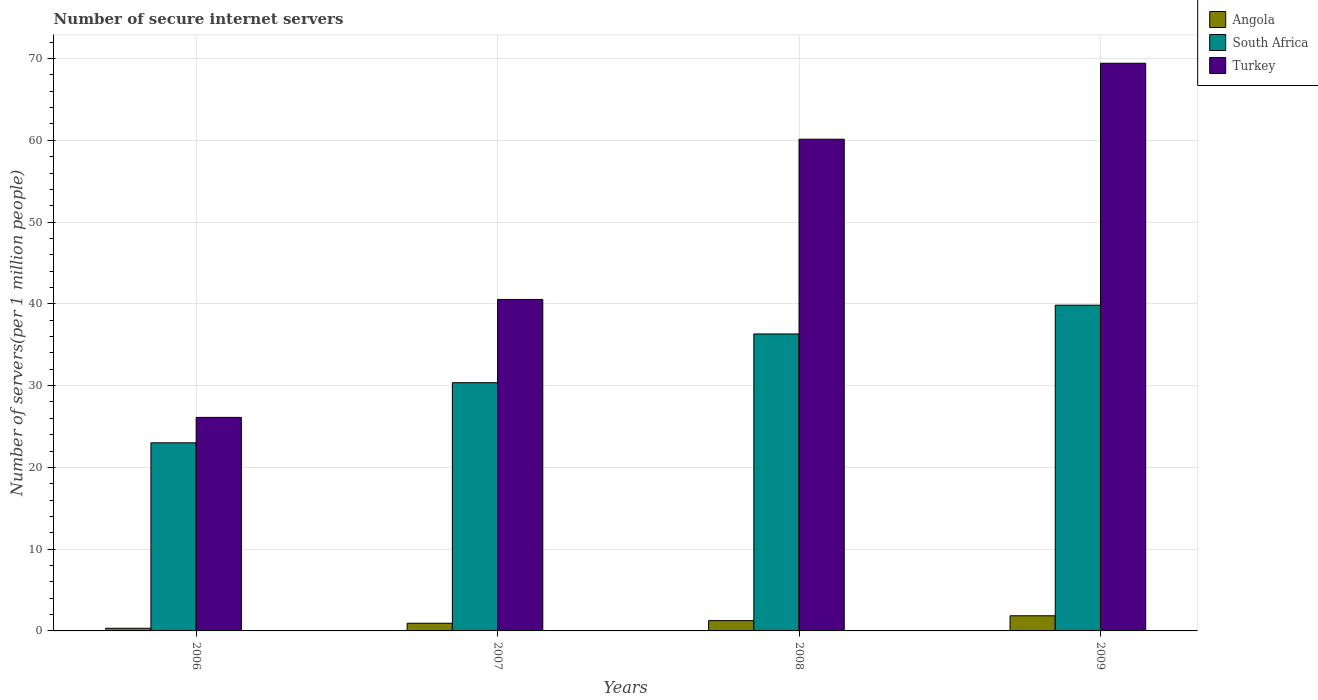Are the number of bars per tick equal to the number of legend labels?
Provide a short and direct response. Yes. Are the number of bars on each tick of the X-axis equal?
Your answer should be very brief. Yes. How many bars are there on the 3rd tick from the right?
Your response must be concise. 3. What is the number of secure internet servers in South Africa in 2009?
Your answer should be very brief. 39.84. Across all years, what is the maximum number of secure internet servers in Turkey?
Offer a very short reply. 69.42. Across all years, what is the minimum number of secure internet servers in Angola?
Your response must be concise. 0.32. In which year was the number of secure internet servers in Turkey minimum?
Give a very brief answer. 2006. What is the total number of secure internet servers in Turkey in the graph?
Your answer should be compact. 196.2. What is the difference between the number of secure internet servers in South Africa in 2007 and that in 2008?
Make the answer very short. -5.96. What is the difference between the number of secure internet servers in South Africa in 2008 and the number of secure internet servers in Angola in 2006?
Your answer should be compact. 35.99. What is the average number of secure internet servers in South Africa per year?
Your response must be concise. 32.38. In the year 2008, what is the difference between the number of secure internet servers in South Africa and number of secure internet servers in Turkey?
Provide a short and direct response. -23.82. In how many years, is the number of secure internet servers in South Africa greater than 2?
Provide a short and direct response. 4. What is the ratio of the number of secure internet servers in South Africa in 2006 to that in 2008?
Give a very brief answer. 0.63. Is the number of secure internet servers in Turkey in 2008 less than that in 2009?
Ensure brevity in your answer.  Yes. Is the difference between the number of secure internet servers in South Africa in 2006 and 2009 greater than the difference between the number of secure internet servers in Turkey in 2006 and 2009?
Keep it short and to the point. Yes. What is the difference between the highest and the second highest number of secure internet servers in Turkey?
Provide a short and direct response. 9.29. What is the difference between the highest and the lowest number of secure internet servers in South Africa?
Ensure brevity in your answer.  16.83. Is the sum of the number of secure internet servers in Angola in 2006 and 2007 greater than the maximum number of secure internet servers in Turkey across all years?
Your answer should be very brief. No. What does the 2nd bar from the left in 2006 represents?
Ensure brevity in your answer.  South Africa. What does the 2nd bar from the right in 2009 represents?
Make the answer very short. South Africa. How many bars are there?
Provide a succinct answer. 12. Are the values on the major ticks of Y-axis written in scientific E-notation?
Your answer should be compact. No. Does the graph contain any zero values?
Offer a very short reply. No. What is the title of the graph?
Provide a succinct answer. Number of secure internet servers. What is the label or title of the Y-axis?
Give a very brief answer. Number of servers(per 1 million people). What is the Number of servers(per 1 million people) of Angola in 2006?
Your answer should be compact. 0.32. What is the Number of servers(per 1 million people) in South Africa in 2006?
Your response must be concise. 23. What is the Number of servers(per 1 million people) of Turkey in 2006?
Provide a succinct answer. 26.11. What is the Number of servers(per 1 million people) of Angola in 2007?
Your response must be concise. 0.94. What is the Number of servers(per 1 million people) of South Africa in 2007?
Offer a terse response. 30.36. What is the Number of servers(per 1 million people) of Turkey in 2007?
Ensure brevity in your answer.  40.54. What is the Number of servers(per 1 million people) of Angola in 2008?
Your response must be concise. 1.26. What is the Number of servers(per 1 million people) of South Africa in 2008?
Give a very brief answer. 36.32. What is the Number of servers(per 1 million people) in Turkey in 2008?
Your answer should be compact. 60.13. What is the Number of servers(per 1 million people) of Angola in 2009?
Make the answer very short. 1.85. What is the Number of servers(per 1 million people) of South Africa in 2009?
Give a very brief answer. 39.84. What is the Number of servers(per 1 million people) of Turkey in 2009?
Keep it short and to the point. 69.42. Across all years, what is the maximum Number of servers(per 1 million people) of Angola?
Ensure brevity in your answer.  1.85. Across all years, what is the maximum Number of servers(per 1 million people) of South Africa?
Keep it short and to the point. 39.84. Across all years, what is the maximum Number of servers(per 1 million people) in Turkey?
Provide a succinct answer. 69.42. Across all years, what is the minimum Number of servers(per 1 million people) of Angola?
Provide a succinct answer. 0.32. Across all years, what is the minimum Number of servers(per 1 million people) of South Africa?
Provide a succinct answer. 23. Across all years, what is the minimum Number of servers(per 1 million people) in Turkey?
Make the answer very short. 26.11. What is the total Number of servers(per 1 million people) in Angola in the graph?
Your response must be concise. 4.37. What is the total Number of servers(per 1 million people) in South Africa in the graph?
Your answer should be very brief. 129.51. What is the total Number of servers(per 1 million people) of Turkey in the graph?
Keep it short and to the point. 196.2. What is the difference between the Number of servers(per 1 million people) of Angola in 2006 and that in 2007?
Your answer should be very brief. -0.61. What is the difference between the Number of servers(per 1 million people) of South Africa in 2006 and that in 2007?
Your answer should be very brief. -7.35. What is the difference between the Number of servers(per 1 million people) of Turkey in 2006 and that in 2007?
Offer a very short reply. -14.43. What is the difference between the Number of servers(per 1 million people) in Angola in 2006 and that in 2008?
Your answer should be compact. -0.94. What is the difference between the Number of servers(per 1 million people) of South Africa in 2006 and that in 2008?
Provide a short and direct response. -13.31. What is the difference between the Number of servers(per 1 million people) of Turkey in 2006 and that in 2008?
Your response must be concise. -34.02. What is the difference between the Number of servers(per 1 million people) in Angola in 2006 and that in 2009?
Your answer should be compact. -1.53. What is the difference between the Number of servers(per 1 million people) in South Africa in 2006 and that in 2009?
Your answer should be very brief. -16.83. What is the difference between the Number of servers(per 1 million people) in Turkey in 2006 and that in 2009?
Offer a very short reply. -43.31. What is the difference between the Number of servers(per 1 million people) of Angola in 2007 and that in 2008?
Offer a terse response. -0.32. What is the difference between the Number of servers(per 1 million people) of South Africa in 2007 and that in 2008?
Provide a succinct answer. -5.96. What is the difference between the Number of servers(per 1 million people) of Turkey in 2007 and that in 2008?
Offer a terse response. -19.59. What is the difference between the Number of servers(per 1 million people) in Angola in 2007 and that in 2009?
Your answer should be compact. -0.91. What is the difference between the Number of servers(per 1 million people) in South Africa in 2007 and that in 2009?
Offer a terse response. -9.48. What is the difference between the Number of servers(per 1 million people) in Turkey in 2007 and that in 2009?
Offer a terse response. -28.88. What is the difference between the Number of servers(per 1 million people) of Angola in 2008 and that in 2009?
Provide a succinct answer. -0.59. What is the difference between the Number of servers(per 1 million people) in South Africa in 2008 and that in 2009?
Keep it short and to the point. -3.52. What is the difference between the Number of servers(per 1 million people) of Turkey in 2008 and that in 2009?
Ensure brevity in your answer.  -9.29. What is the difference between the Number of servers(per 1 million people) in Angola in 2006 and the Number of servers(per 1 million people) in South Africa in 2007?
Ensure brevity in your answer.  -30.03. What is the difference between the Number of servers(per 1 million people) of Angola in 2006 and the Number of servers(per 1 million people) of Turkey in 2007?
Give a very brief answer. -40.21. What is the difference between the Number of servers(per 1 million people) in South Africa in 2006 and the Number of servers(per 1 million people) in Turkey in 2007?
Your response must be concise. -17.53. What is the difference between the Number of servers(per 1 million people) in Angola in 2006 and the Number of servers(per 1 million people) in South Africa in 2008?
Offer a terse response. -35.99. What is the difference between the Number of servers(per 1 million people) of Angola in 2006 and the Number of servers(per 1 million people) of Turkey in 2008?
Provide a short and direct response. -59.81. What is the difference between the Number of servers(per 1 million people) in South Africa in 2006 and the Number of servers(per 1 million people) in Turkey in 2008?
Keep it short and to the point. -37.13. What is the difference between the Number of servers(per 1 million people) of Angola in 2006 and the Number of servers(per 1 million people) of South Africa in 2009?
Ensure brevity in your answer.  -39.51. What is the difference between the Number of servers(per 1 million people) of Angola in 2006 and the Number of servers(per 1 million people) of Turkey in 2009?
Keep it short and to the point. -69.1. What is the difference between the Number of servers(per 1 million people) in South Africa in 2006 and the Number of servers(per 1 million people) in Turkey in 2009?
Give a very brief answer. -46.42. What is the difference between the Number of servers(per 1 million people) in Angola in 2007 and the Number of servers(per 1 million people) in South Africa in 2008?
Your response must be concise. -35.38. What is the difference between the Number of servers(per 1 million people) in Angola in 2007 and the Number of servers(per 1 million people) in Turkey in 2008?
Keep it short and to the point. -59.19. What is the difference between the Number of servers(per 1 million people) in South Africa in 2007 and the Number of servers(per 1 million people) in Turkey in 2008?
Your response must be concise. -29.78. What is the difference between the Number of servers(per 1 million people) of Angola in 2007 and the Number of servers(per 1 million people) of South Africa in 2009?
Offer a very short reply. -38.9. What is the difference between the Number of servers(per 1 million people) in Angola in 2007 and the Number of servers(per 1 million people) in Turkey in 2009?
Give a very brief answer. -68.48. What is the difference between the Number of servers(per 1 million people) in South Africa in 2007 and the Number of servers(per 1 million people) in Turkey in 2009?
Offer a very short reply. -39.06. What is the difference between the Number of servers(per 1 million people) of Angola in 2008 and the Number of servers(per 1 million people) of South Africa in 2009?
Your answer should be compact. -38.58. What is the difference between the Number of servers(per 1 million people) of Angola in 2008 and the Number of servers(per 1 million people) of Turkey in 2009?
Keep it short and to the point. -68.16. What is the difference between the Number of servers(per 1 million people) of South Africa in 2008 and the Number of servers(per 1 million people) of Turkey in 2009?
Your answer should be compact. -33.1. What is the average Number of servers(per 1 million people) of Angola per year?
Offer a very short reply. 1.09. What is the average Number of servers(per 1 million people) in South Africa per year?
Make the answer very short. 32.38. What is the average Number of servers(per 1 million people) of Turkey per year?
Offer a very short reply. 49.05. In the year 2006, what is the difference between the Number of servers(per 1 million people) of Angola and Number of servers(per 1 million people) of South Africa?
Make the answer very short. -22.68. In the year 2006, what is the difference between the Number of servers(per 1 million people) in Angola and Number of servers(per 1 million people) in Turkey?
Your answer should be very brief. -25.79. In the year 2006, what is the difference between the Number of servers(per 1 million people) of South Africa and Number of servers(per 1 million people) of Turkey?
Make the answer very short. -3.11. In the year 2007, what is the difference between the Number of servers(per 1 million people) in Angola and Number of servers(per 1 million people) in South Africa?
Offer a terse response. -29.42. In the year 2007, what is the difference between the Number of servers(per 1 million people) in Angola and Number of servers(per 1 million people) in Turkey?
Make the answer very short. -39.6. In the year 2007, what is the difference between the Number of servers(per 1 million people) in South Africa and Number of servers(per 1 million people) in Turkey?
Your answer should be compact. -10.18. In the year 2008, what is the difference between the Number of servers(per 1 million people) in Angola and Number of servers(per 1 million people) in South Africa?
Make the answer very short. -35.06. In the year 2008, what is the difference between the Number of servers(per 1 million people) of Angola and Number of servers(per 1 million people) of Turkey?
Offer a terse response. -58.87. In the year 2008, what is the difference between the Number of servers(per 1 million people) of South Africa and Number of servers(per 1 million people) of Turkey?
Your response must be concise. -23.82. In the year 2009, what is the difference between the Number of servers(per 1 million people) of Angola and Number of servers(per 1 million people) of South Africa?
Ensure brevity in your answer.  -37.98. In the year 2009, what is the difference between the Number of servers(per 1 million people) in Angola and Number of servers(per 1 million people) in Turkey?
Ensure brevity in your answer.  -67.57. In the year 2009, what is the difference between the Number of servers(per 1 million people) of South Africa and Number of servers(per 1 million people) of Turkey?
Provide a succinct answer. -29.58. What is the ratio of the Number of servers(per 1 million people) of Angola in 2006 to that in 2007?
Your response must be concise. 0.34. What is the ratio of the Number of servers(per 1 million people) of South Africa in 2006 to that in 2007?
Keep it short and to the point. 0.76. What is the ratio of the Number of servers(per 1 million people) in Turkey in 2006 to that in 2007?
Your answer should be very brief. 0.64. What is the ratio of the Number of servers(per 1 million people) of Angola in 2006 to that in 2008?
Keep it short and to the point. 0.26. What is the ratio of the Number of servers(per 1 million people) of South Africa in 2006 to that in 2008?
Ensure brevity in your answer.  0.63. What is the ratio of the Number of servers(per 1 million people) in Turkey in 2006 to that in 2008?
Make the answer very short. 0.43. What is the ratio of the Number of servers(per 1 million people) in Angola in 2006 to that in 2009?
Provide a succinct answer. 0.17. What is the ratio of the Number of servers(per 1 million people) of South Africa in 2006 to that in 2009?
Your answer should be very brief. 0.58. What is the ratio of the Number of servers(per 1 million people) in Turkey in 2006 to that in 2009?
Make the answer very short. 0.38. What is the ratio of the Number of servers(per 1 million people) of Angola in 2007 to that in 2008?
Your answer should be compact. 0.74. What is the ratio of the Number of servers(per 1 million people) of South Africa in 2007 to that in 2008?
Ensure brevity in your answer.  0.84. What is the ratio of the Number of servers(per 1 million people) of Turkey in 2007 to that in 2008?
Provide a succinct answer. 0.67. What is the ratio of the Number of servers(per 1 million people) in Angola in 2007 to that in 2009?
Give a very brief answer. 0.51. What is the ratio of the Number of servers(per 1 million people) in South Africa in 2007 to that in 2009?
Offer a terse response. 0.76. What is the ratio of the Number of servers(per 1 million people) of Turkey in 2007 to that in 2009?
Offer a terse response. 0.58. What is the ratio of the Number of servers(per 1 million people) of Angola in 2008 to that in 2009?
Ensure brevity in your answer.  0.68. What is the ratio of the Number of servers(per 1 million people) of South Africa in 2008 to that in 2009?
Ensure brevity in your answer.  0.91. What is the ratio of the Number of servers(per 1 million people) of Turkey in 2008 to that in 2009?
Ensure brevity in your answer.  0.87. What is the difference between the highest and the second highest Number of servers(per 1 million people) of Angola?
Ensure brevity in your answer.  0.59. What is the difference between the highest and the second highest Number of servers(per 1 million people) of South Africa?
Give a very brief answer. 3.52. What is the difference between the highest and the second highest Number of servers(per 1 million people) of Turkey?
Give a very brief answer. 9.29. What is the difference between the highest and the lowest Number of servers(per 1 million people) in Angola?
Ensure brevity in your answer.  1.53. What is the difference between the highest and the lowest Number of servers(per 1 million people) in South Africa?
Offer a very short reply. 16.83. What is the difference between the highest and the lowest Number of servers(per 1 million people) in Turkey?
Offer a terse response. 43.31. 